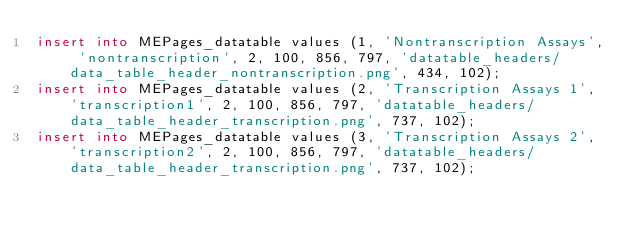Convert code to text. <code><loc_0><loc_0><loc_500><loc_500><_SQL_>insert into MEPages_datatable values (1, 'Nontranscription Assays', 'nontranscription', 2, 100, 856, 797, 'datatable_headers/data_table_header_nontranscription.png', 434, 102);
insert into MEPages_datatable values (2, 'Transcription Assays 1', 'transcription1', 2, 100, 856, 797, 'datatable_headers/data_table_header_transcription.png', 737, 102);
insert into MEPages_datatable values (3, 'Transcription Assays 2', 'transcription2', 2, 100, 856, 797, 'datatable_headers/data_table_header_transcription.png', 737, 102);

</code> 